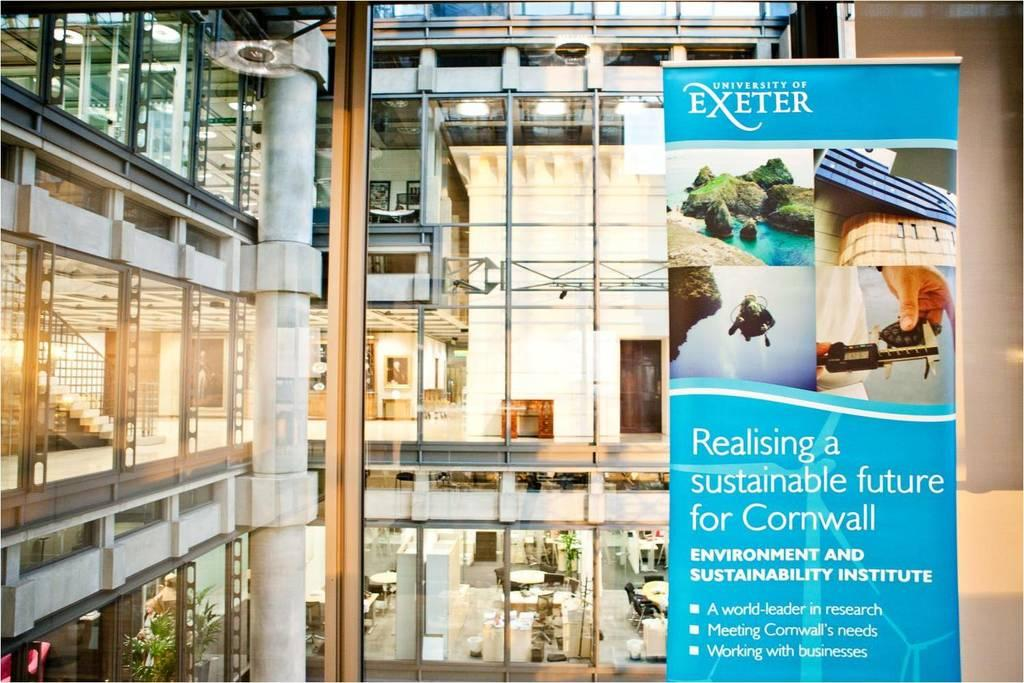<image>
Render a clear and concise summary of the photo. A brochure for the University of Exeter says Realising a sustainable future for Cornwall and is displayed in front of a building of glass windows. 